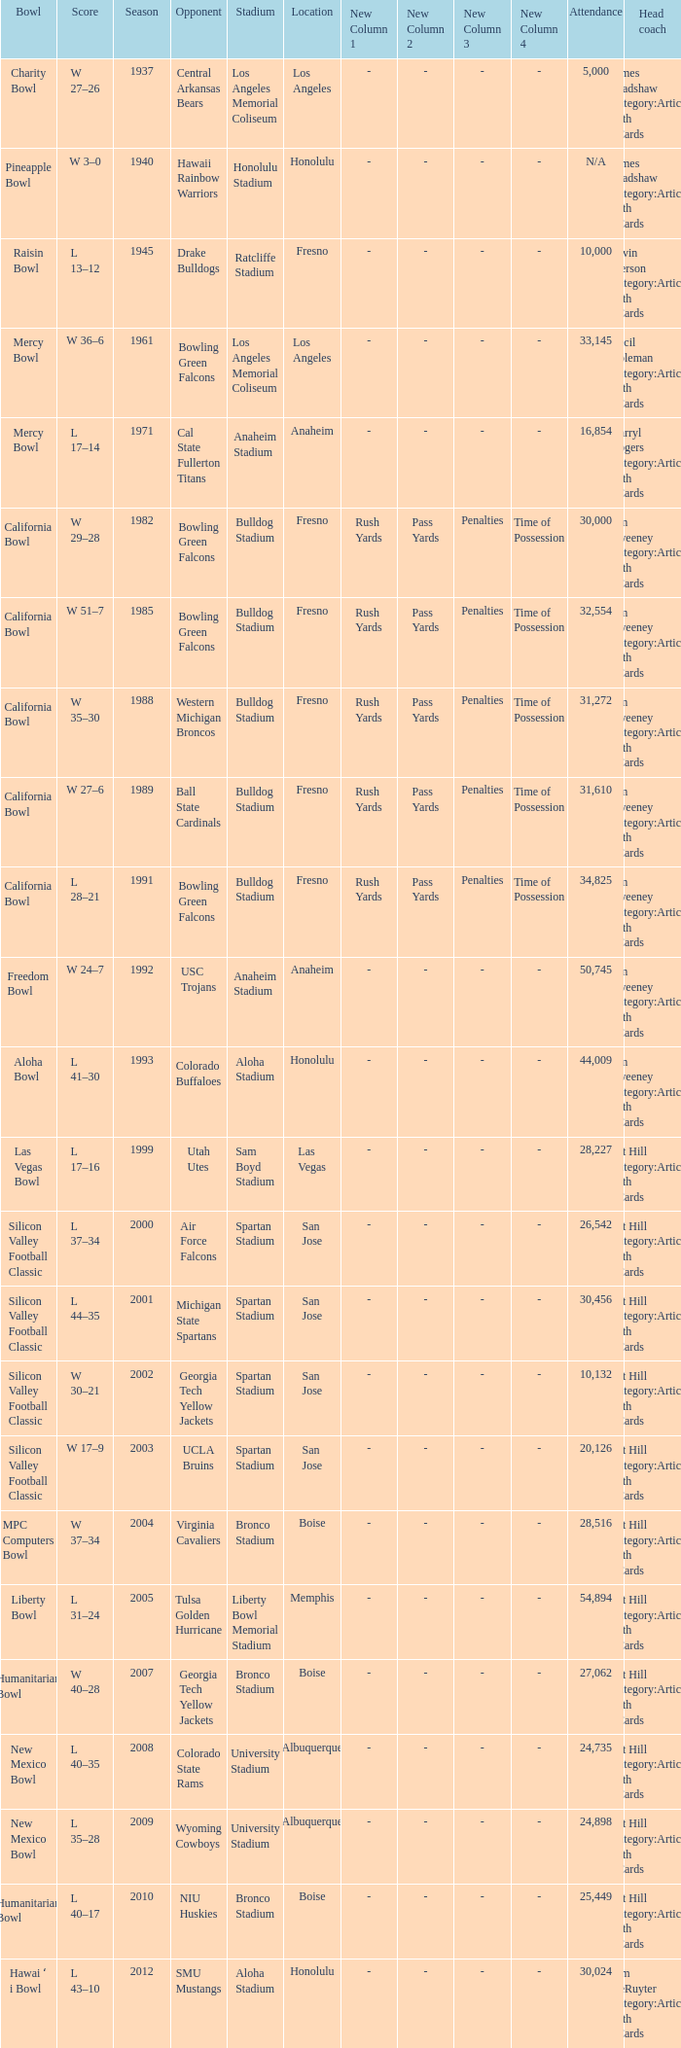Would you be able to parse every entry in this table? {'header': ['Bowl', 'Score', 'Season', 'Opponent', 'Stadium', 'Location', 'New Column 1', 'New Column 2', 'New Column 3', 'New Column 4', 'Attendance', 'Head coach'], 'rows': [['Charity Bowl', 'W 27–26', '1937', 'Central Arkansas Bears', 'Los Angeles Memorial Coliseum', 'Los Angeles', '-', '-', '-', '-', '5,000', 'James Bradshaw Category:Articles with hCards'], ['Pineapple Bowl', 'W 3–0', '1940', 'Hawaii Rainbow Warriors', 'Honolulu Stadium', 'Honolulu', '-', '-', '-', '-', 'N/A', 'James Bradshaw Category:Articles with hCards'], ['Raisin Bowl', 'L 13–12', '1945', 'Drake Bulldogs', 'Ratcliffe Stadium', 'Fresno', '-', '-', '-', '-', '10,000', 'Alvin Pierson Category:Articles with hCards'], ['Mercy Bowl', 'W 36–6', '1961', 'Bowling Green Falcons', 'Los Angeles Memorial Coliseum', 'Los Angeles', '-', '-', '-', '-', '33,145', 'Cecil Coleman Category:Articles with hCards'], ['Mercy Bowl', 'L 17–14', '1971', 'Cal State Fullerton Titans', 'Anaheim Stadium', 'Anaheim', '-', '-', '-', '-', '16,854', 'Darryl Rogers Category:Articles with hCards'], ['California Bowl', 'W 29–28', '1982', 'Bowling Green Falcons', 'Bulldog Stadium', 'Fresno', 'Rush Yards', 'Pass Yards', 'Penalties', 'Time of Possession', '30,000', 'Jim Sweeney Category:Articles with hCards'], ['California Bowl', 'W 51–7', '1985', 'Bowling Green Falcons', 'Bulldog Stadium', 'Fresno', 'Rush Yards', 'Pass Yards', 'Penalties', 'Time of Possession', '32,554', 'Jim Sweeney Category:Articles with hCards'], ['California Bowl', 'W 35–30', '1988', 'Western Michigan Broncos', 'Bulldog Stadium', 'Fresno', 'Rush Yards', 'Pass Yards', 'Penalties', 'Time of Possession', '31,272', 'Jim Sweeney Category:Articles with hCards'], ['California Bowl', 'W 27–6', '1989', 'Ball State Cardinals', 'Bulldog Stadium', 'Fresno', 'Rush Yards', 'Pass Yards', 'Penalties', 'Time of Possession', '31,610', 'Jim Sweeney Category:Articles with hCards'], ['California Bowl', 'L 28–21', '1991', 'Bowling Green Falcons', 'Bulldog Stadium', 'Fresno', 'Rush Yards', 'Pass Yards', 'Penalties', 'Time of Possession', '34,825', 'Jim Sweeney Category:Articles with hCards'], ['Freedom Bowl', 'W 24–7', '1992', 'USC Trojans', 'Anaheim Stadium', 'Anaheim', '-', '-', '-', '-', '50,745', 'Jim Sweeney Category:Articles with hCards'], ['Aloha Bowl', 'L 41–30', '1993', 'Colorado Buffaloes', 'Aloha Stadium', 'Honolulu', '-', '-', '-', '-', '44,009', 'Jim Sweeney Category:Articles with hCards'], ['Las Vegas Bowl', 'L 17–16', '1999', 'Utah Utes', 'Sam Boyd Stadium', 'Las Vegas', '-', '-', '-', '-', '28,227', 'Pat Hill Category:Articles with hCards'], ['Silicon Valley Football Classic', 'L 37–34', '2000', 'Air Force Falcons', 'Spartan Stadium', 'San Jose', '-', '-', '-', '-', '26,542', 'Pat Hill Category:Articles with hCards'], ['Silicon Valley Football Classic', 'L 44–35', '2001', 'Michigan State Spartans', 'Spartan Stadium', 'San Jose', '-', '-', '-', '-', '30,456', 'Pat Hill Category:Articles with hCards'], ['Silicon Valley Football Classic', 'W 30–21', '2002', 'Georgia Tech Yellow Jackets', 'Spartan Stadium', 'San Jose', '-', '-', '-', '-', '10,132', 'Pat Hill Category:Articles with hCards'], ['Silicon Valley Football Classic', 'W 17–9', '2003', 'UCLA Bruins', 'Spartan Stadium', 'San Jose', '-', '-', '-', '-', '20,126', 'Pat Hill Category:Articles with hCards'], ['MPC Computers Bowl', 'W 37–34', '2004', 'Virginia Cavaliers', 'Bronco Stadium', 'Boise', '-', '-', '-', '-', '28,516', 'Pat Hill Category:Articles with hCards'], ['Liberty Bowl', 'L 31–24', '2005', 'Tulsa Golden Hurricane', 'Liberty Bowl Memorial Stadium', 'Memphis', '-', '-', '-', '-', '54,894', 'Pat Hill Category:Articles with hCards'], ['Humanitarian Bowl', 'W 40–28', '2007', 'Georgia Tech Yellow Jackets', 'Bronco Stadium', 'Boise', '-', '-', '-', '-', '27,062', 'Pat Hill Category:Articles with hCards'], ['New Mexico Bowl', 'L 40–35', '2008', 'Colorado State Rams', 'University Stadium', 'Albuquerque', '-', '-', '-', '-', '24,735', 'Pat Hill Category:Articles with hCards'], ['New Mexico Bowl', 'L 35–28', '2009', 'Wyoming Cowboys', 'University Stadium', 'Albuquerque', '-', '-', '-', '-', '24,898', 'Pat Hill Category:Articles with hCards'], ['Humanitarian Bowl', 'L 40–17', '2010', 'NIU Huskies', 'Bronco Stadium', 'Boise', '-', '-', '-', '-', '25,449', 'Pat Hill Category:Articles with hCards'], ['Hawai ʻ i Bowl', 'L 43–10', '2012', 'SMU Mustangs', 'Aloha Stadium', 'Honolulu', '-', '-', '-', '-', '30,024', 'Tim DeRuyter Category:Articles with hCards']]} What stadium had an opponent of Cal State Fullerton Titans? Anaheim Stadium. 